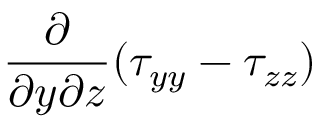<formula> <loc_0><loc_0><loc_500><loc_500>\frac { \partial } { \partial y \partial z } ( \tau _ { y y } - \tau _ { z z } )</formula> 